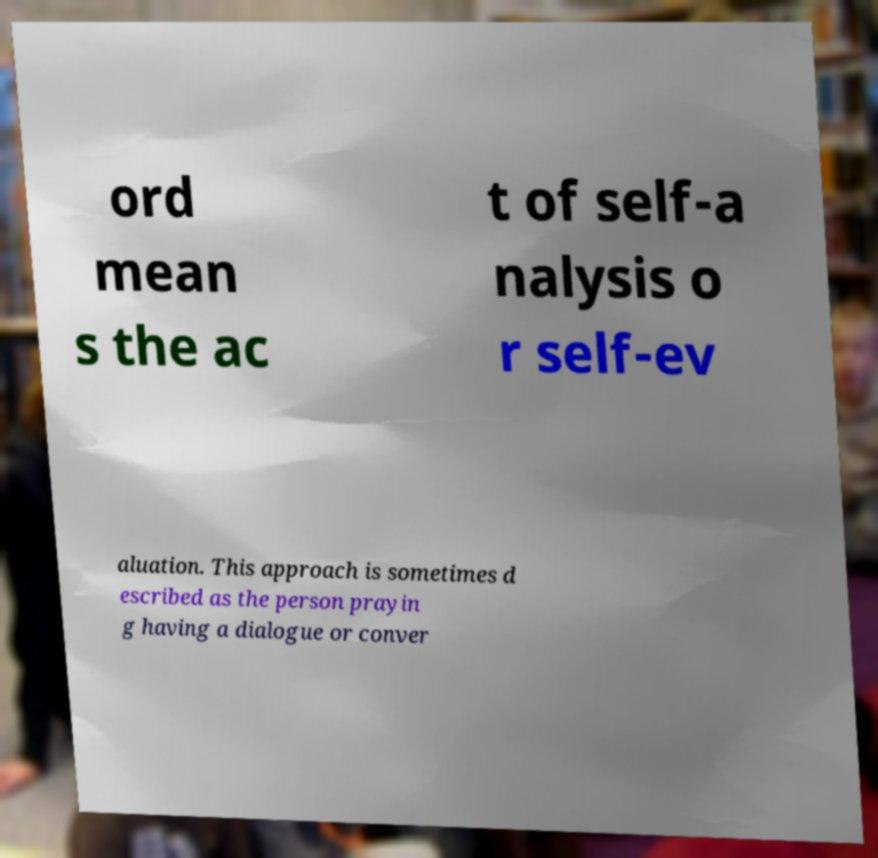Can you accurately transcribe the text from the provided image for me? ord mean s the ac t of self-a nalysis o r self-ev aluation. This approach is sometimes d escribed as the person prayin g having a dialogue or conver 